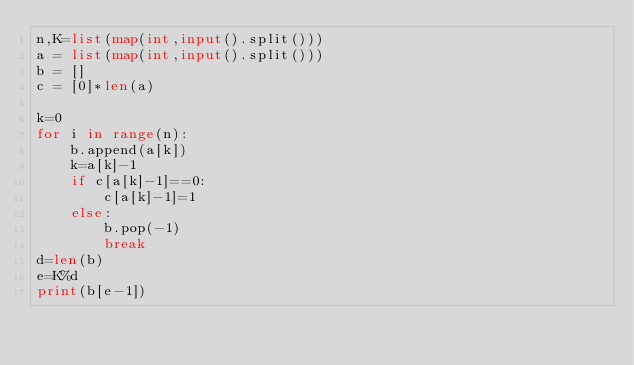Convert code to text. <code><loc_0><loc_0><loc_500><loc_500><_Python_>n,K=list(map(int,input().split()))
a = list(map(int,input().split()))
b = []
c = [0]*len(a)

k=0
for i in range(n):
    b.append(a[k])
    k=a[k]-1
    if c[a[k]-1]==0:
        c[a[k]-1]=1
    else:
        b.pop(-1)
        break
d=len(b)
e=K%d
print(b[e-1])</code> 